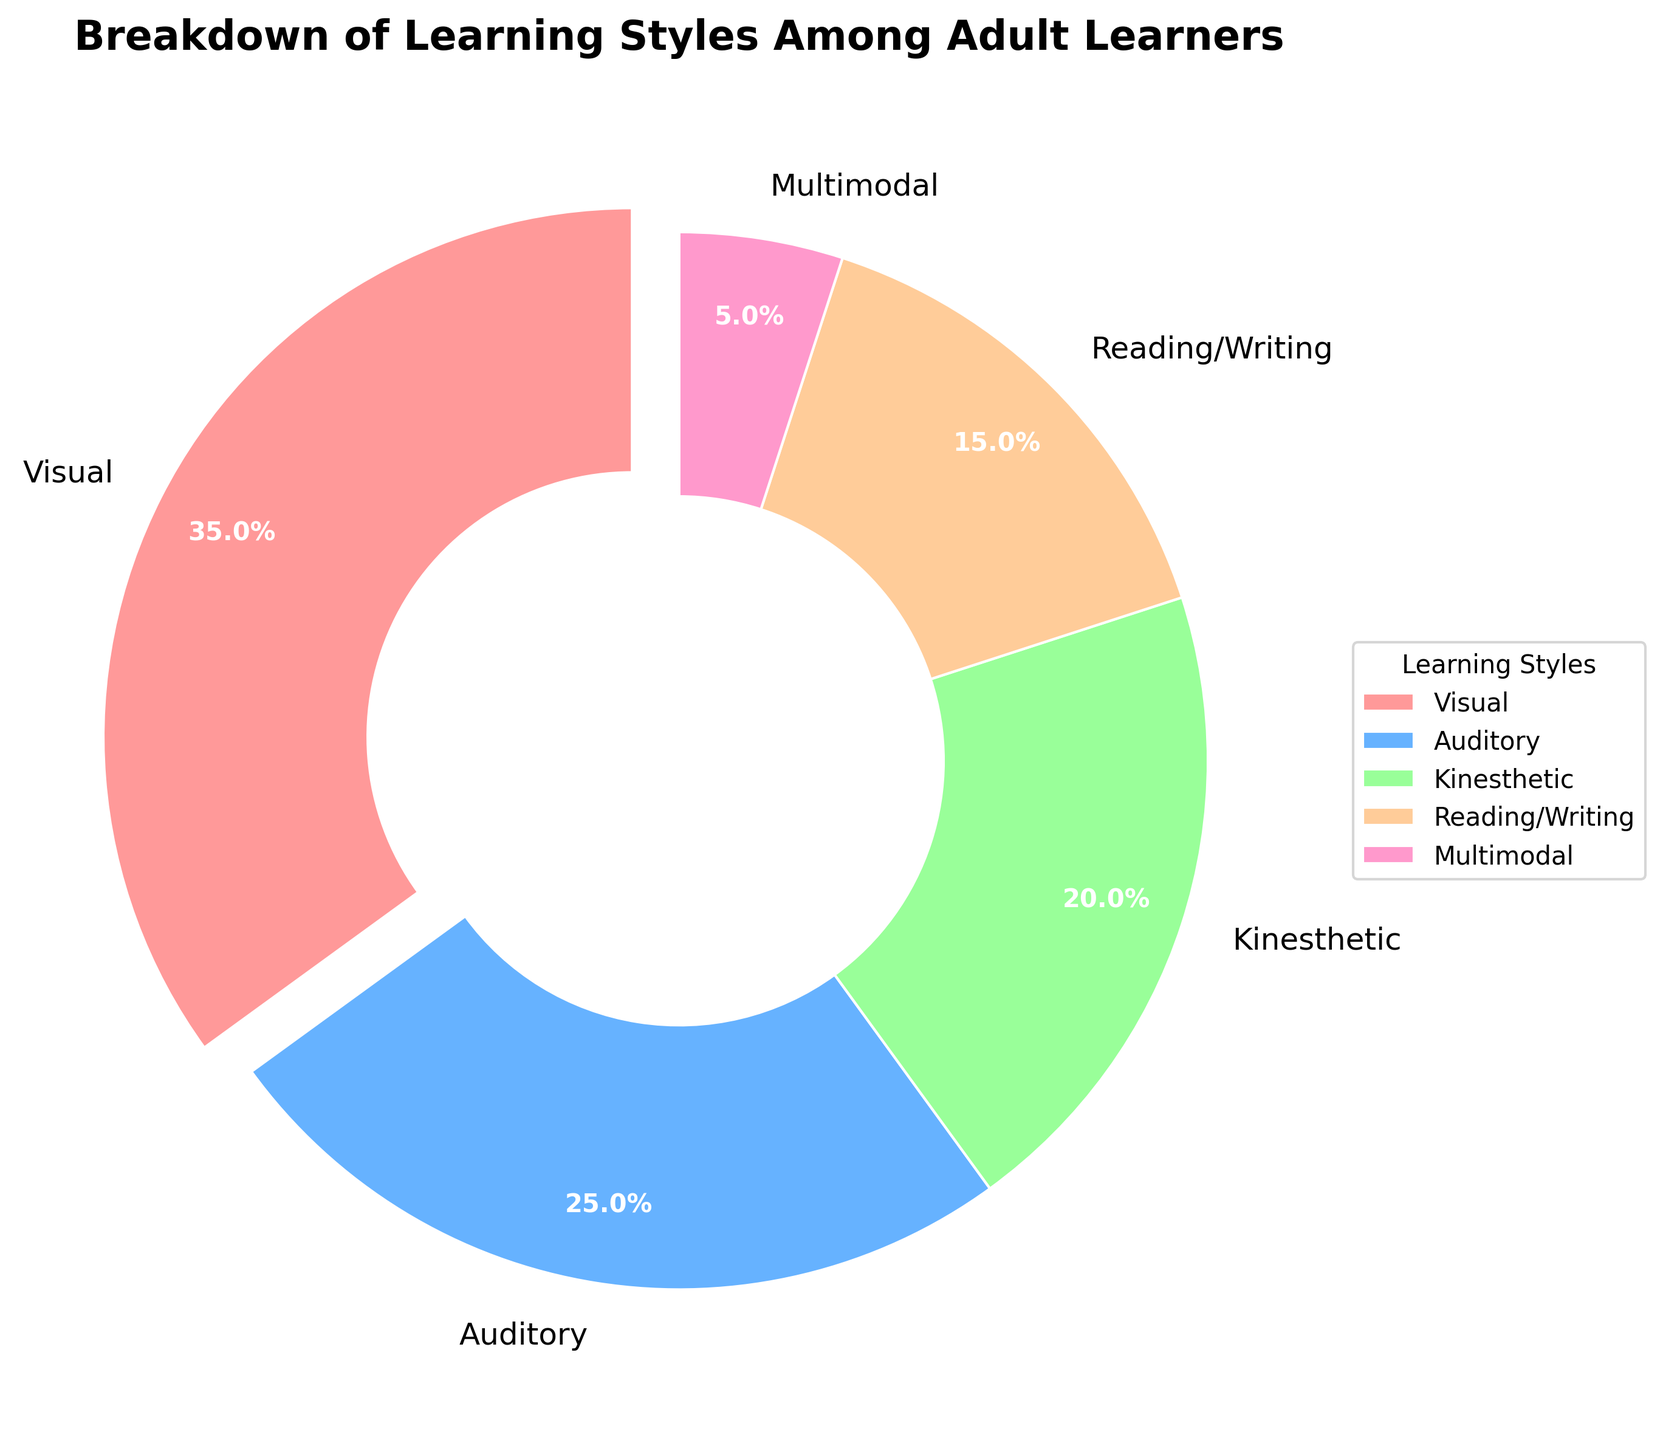What percentage of adult learners have a multimodal learning style? Find the data segment labeled "Multimodal" in the figure and read the percentage value associated with it, which is clearly marked.
Answer: 5% Which learning style is the most common among adult learners? Look for the largest wedge in the pie chart along with its label. The largest wedge is associated with "Visual" learning style.
Answer: Visual What's the combined percentage of auditory and kinesthetic learners? Find the data segments labeled "Auditory" and "Kinesthetic" in the figure and sum their percentages: 25% + 20%.
Answer: 45% Is the percentage of reading/writing learners more or less than 20%? Locate the "Reading/Writing" segment and compare its percentage (15%) with 20%. The percentage is less than 20%.
Answer: Less than 20% Which learning style uses the second largest wedge in the pie chart? Identify the second largest wedge, which corresponds to the "Auditory" learning style.
Answer: Auditory What percentage of learners prefer either visual or reading/writing styles? Add the percentages for "Visual" (35%) and "Reading/Writing" (15%): 35% + 15%.
Answer: 50% How much more common are visual learners compared to kinesthetic learners? Subtract the percentage for kinesthetic learners (20%) from the percentage for visual learners (35%): 35% - 20%.
Answer: 15% Are there fewer auditory style learners than kinesthetic and reading/writing learners combined? Add the percentages for "Kinesthetic" (20%) and "Reading/Writing" (15%) and compare it with the percentage for "Auditory" (25%): 20% + 15% = 35%, which is more than 25%.
Answer: Yes What is the total percentage of learners who prefer a single mode style (Visual, Auditory, Kinesthetic, Reading/Writing)? Sum the percentages for "Visual" (35%), "Auditory" (25%), "Kinesthetic" (20%), and "Reading/Writing" (15%): 35% + 25% + 20% + 15%.
Answer: 95% Which segment in the pie chart uses the color green? Identify the color green and its associated label in the pie chart. The segment colored green corresponds to "Kinesthetic."
Answer: Kinesthetic 